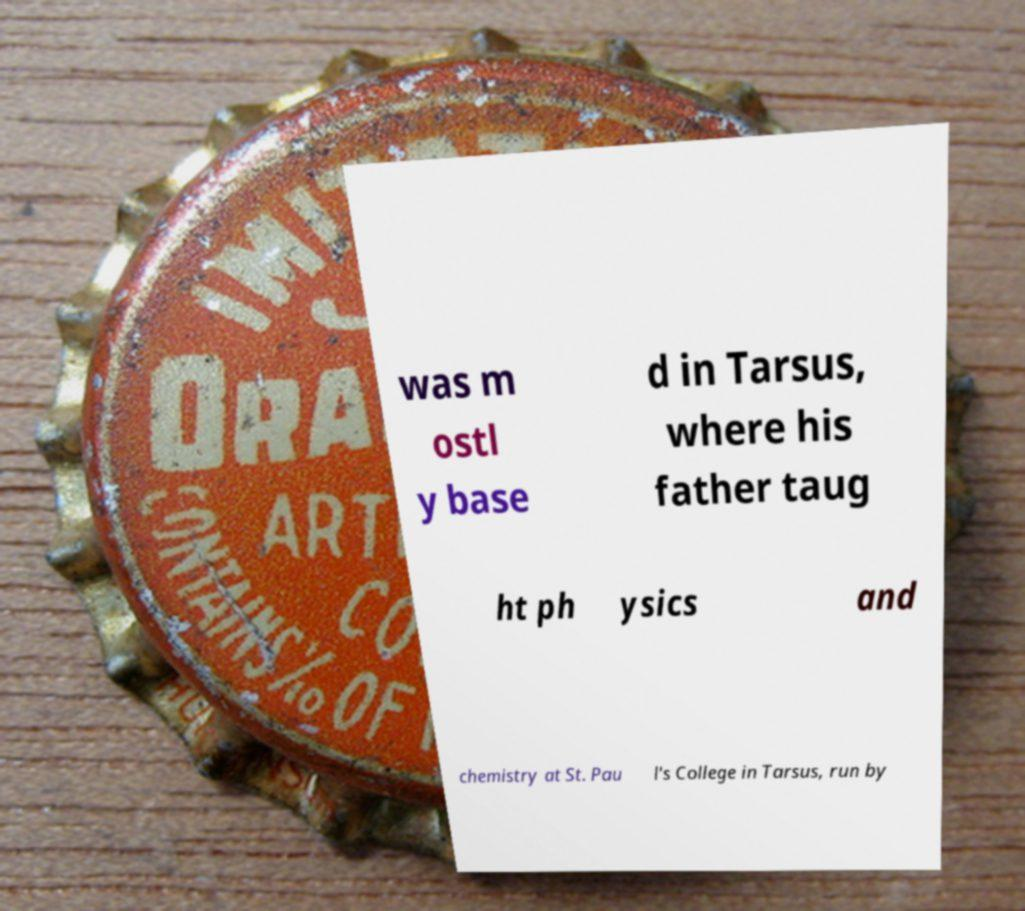Please read and relay the text visible in this image. What does it say? was m ostl y base d in Tarsus, where his father taug ht ph ysics and chemistry at St. Pau l's College in Tarsus, run by 